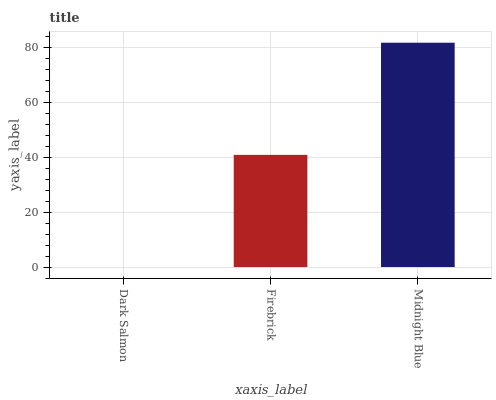Is Firebrick the minimum?
Answer yes or no. No. Is Firebrick the maximum?
Answer yes or no. No. Is Firebrick greater than Dark Salmon?
Answer yes or no. Yes. Is Dark Salmon less than Firebrick?
Answer yes or no. Yes. Is Dark Salmon greater than Firebrick?
Answer yes or no. No. Is Firebrick less than Dark Salmon?
Answer yes or no. No. Is Firebrick the high median?
Answer yes or no. Yes. Is Firebrick the low median?
Answer yes or no. Yes. Is Dark Salmon the high median?
Answer yes or no. No. Is Dark Salmon the low median?
Answer yes or no. No. 